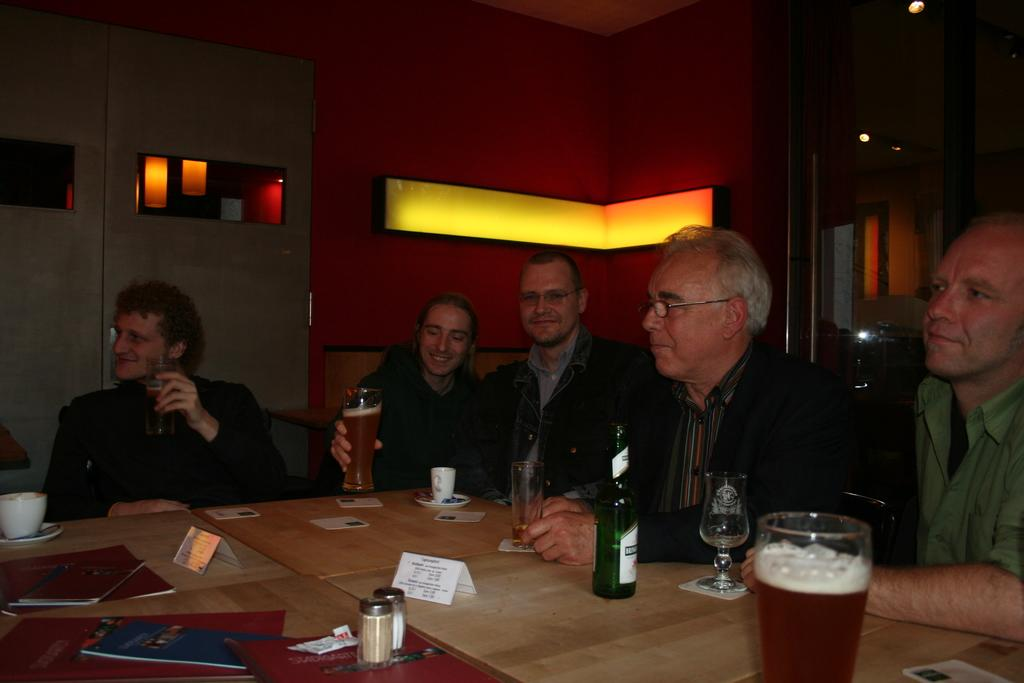What are the people in the image doing? The people in the image are sitting. Can you describe the expressions on their faces? Some people have smiles on their faces. What is present on the table in the image? There is a bottle and glasses on the table. How many ants can be seen crawling on the table in the image? There are no ants visible in the image. What type of hole is present in the table in the image? There is no hole present in the table in the image. 